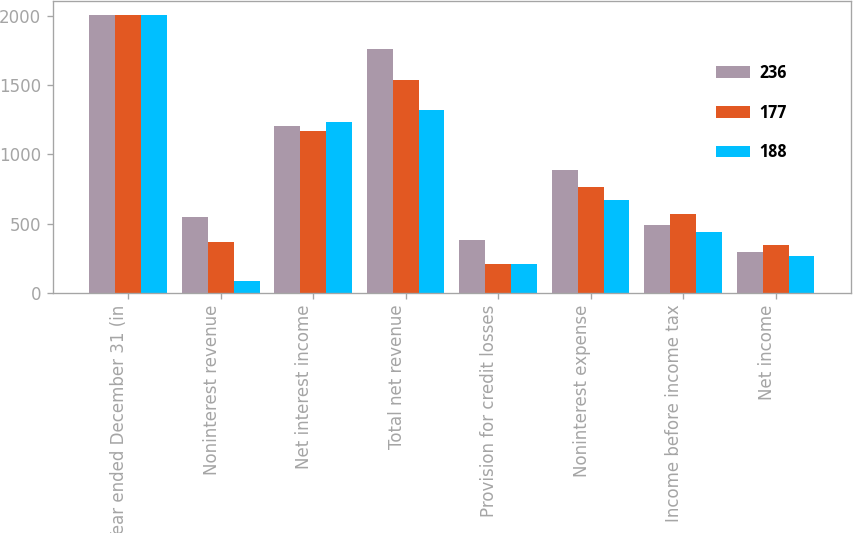<chart> <loc_0><loc_0><loc_500><loc_500><stacked_bar_chart><ecel><fcel>Year ended December 31 (in<fcel>Noninterest revenue<fcel>Net interest income<fcel>Total net revenue<fcel>Provision for credit losses<fcel>Noninterest expense<fcel>Income before income tax<fcel>Net income<nl><fcel>236<fcel>2007<fcel>551<fcel>1206<fcel>1757<fcel>380<fcel>890<fcel>487<fcel>295<nl><fcel>177<fcel>2006<fcel>368<fcel>1171<fcel>1539<fcel>207<fcel>761<fcel>571<fcel>346<nl><fcel>188<fcel>2005<fcel>86<fcel>1235<fcel>1321<fcel>212<fcel>671<fcel>438<fcel>268<nl></chart> 